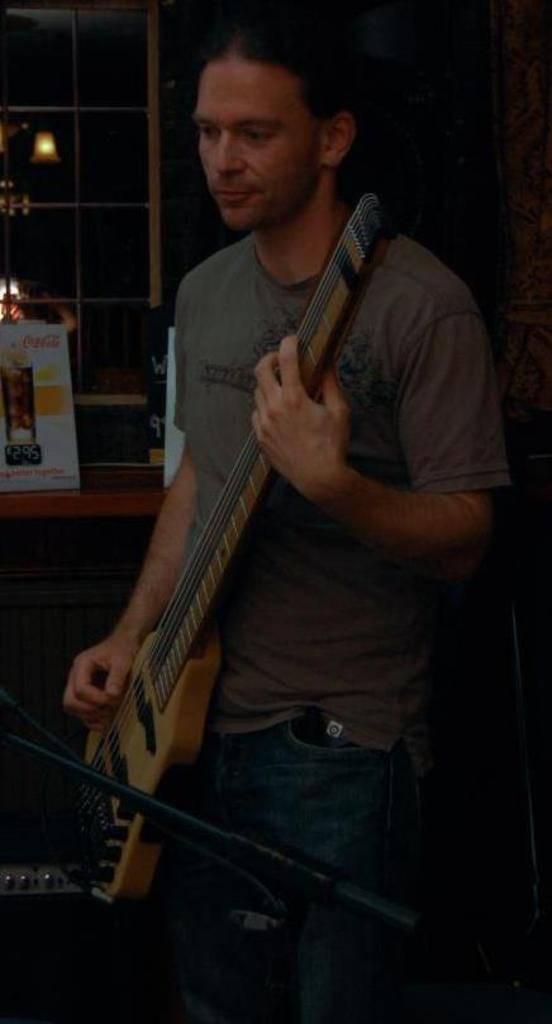What is the person in the image doing? The person is playing a guitar. What object can be seen near the person? There is a table in the image. What is on the table? There is a board on the table. What can be seen in the background of the image? There is a window and a wall lamp in the background of the image. What type of berry is the goat eating in the image? There is no goat or berry present in the image. Is the person in the image a writer? The provided facts do not mention anything about the person being a writer, so we cannot determine that from the image. 